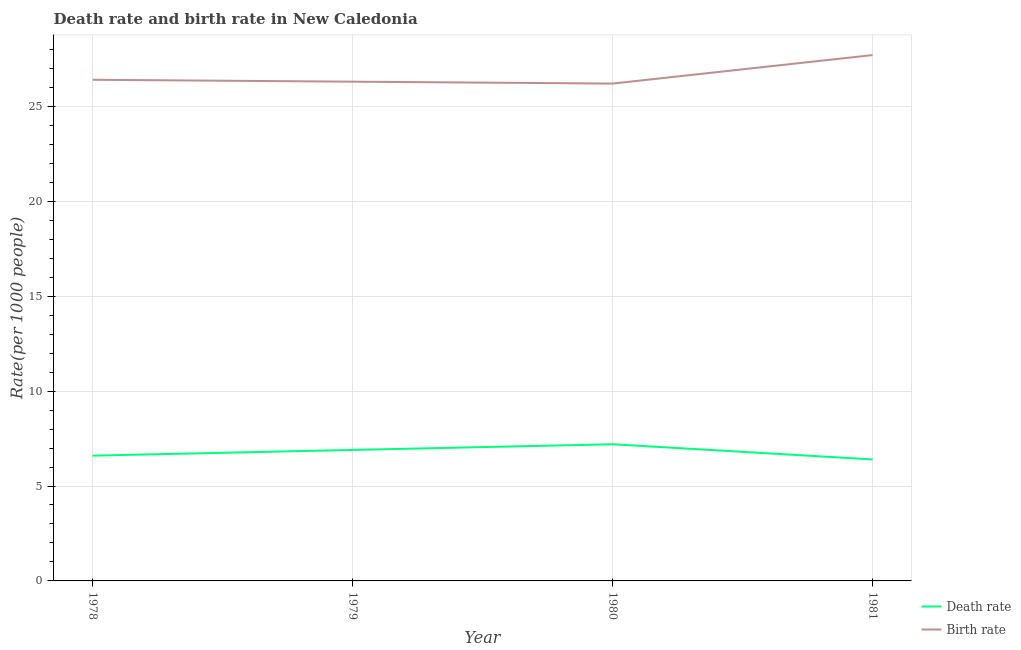How many different coloured lines are there?
Keep it short and to the point. 2. Does the line corresponding to birth rate intersect with the line corresponding to death rate?
Provide a short and direct response. No. Is the number of lines equal to the number of legend labels?
Ensure brevity in your answer.  Yes. What is the death rate in 1978?
Provide a short and direct response. 6.6. Across all years, what is the maximum death rate?
Make the answer very short. 7.2. What is the total death rate in the graph?
Offer a terse response. 27.1. What is the difference between the death rate in 1978 and that in 1980?
Make the answer very short. -0.6. What is the difference between the birth rate in 1979 and the death rate in 1978?
Make the answer very short. 19.7. What is the average death rate per year?
Keep it short and to the point. 6.78. In the year 1981, what is the difference between the birth rate and death rate?
Make the answer very short. 21.3. In how many years, is the death rate greater than 6?
Your response must be concise. 4. What is the ratio of the death rate in 1979 to that in 1981?
Offer a very short reply. 1.08. Is the death rate in 1980 less than that in 1981?
Keep it short and to the point. No. Is the difference between the death rate in 1978 and 1981 greater than the difference between the birth rate in 1978 and 1981?
Your answer should be compact. Yes. What is the difference between the highest and the second highest birth rate?
Keep it short and to the point. 1.3. What is the difference between the highest and the lowest death rate?
Your response must be concise. 0.8. In how many years, is the death rate greater than the average death rate taken over all years?
Offer a very short reply. 2. Is the sum of the death rate in 1980 and 1981 greater than the maximum birth rate across all years?
Keep it short and to the point. No. Does the death rate monotonically increase over the years?
Your response must be concise. No. Is the death rate strictly greater than the birth rate over the years?
Offer a very short reply. No. How many lines are there?
Keep it short and to the point. 2. How are the legend labels stacked?
Your response must be concise. Vertical. What is the title of the graph?
Ensure brevity in your answer.  Death rate and birth rate in New Caledonia. What is the label or title of the Y-axis?
Offer a terse response. Rate(per 1000 people). What is the Rate(per 1000 people) of Death rate in 1978?
Your answer should be very brief. 6.6. What is the Rate(per 1000 people) in Birth rate in 1978?
Provide a succinct answer. 26.4. What is the Rate(per 1000 people) of Death rate in 1979?
Your response must be concise. 6.9. What is the Rate(per 1000 people) in Birth rate in 1979?
Make the answer very short. 26.3. What is the Rate(per 1000 people) in Death rate in 1980?
Your response must be concise. 7.2. What is the Rate(per 1000 people) of Birth rate in 1980?
Offer a very short reply. 26.2. What is the Rate(per 1000 people) of Death rate in 1981?
Your answer should be very brief. 6.4. What is the Rate(per 1000 people) of Birth rate in 1981?
Keep it short and to the point. 27.7. Across all years, what is the maximum Rate(per 1000 people) of Death rate?
Make the answer very short. 7.2. Across all years, what is the maximum Rate(per 1000 people) in Birth rate?
Your response must be concise. 27.7. Across all years, what is the minimum Rate(per 1000 people) of Death rate?
Give a very brief answer. 6.4. Across all years, what is the minimum Rate(per 1000 people) in Birth rate?
Offer a very short reply. 26.2. What is the total Rate(per 1000 people) in Death rate in the graph?
Offer a terse response. 27.1. What is the total Rate(per 1000 people) of Birth rate in the graph?
Your response must be concise. 106.6. What is the difference between the Rate(per 1000 people) of Death rate in 1978 and that in 1980?
Keep it short and to the point. -0.6. What is the difference between the Rate(per 1000 people) of Birth rate in 1978 and that in 1980?
Make the answer very short. 0.2. What is the difference between the Rate(per 1000 people) in Death rate in 1978 and that in 1981?
Provide a short and direct response. 0.2. What is the difference between the Rate(per 1000 people) in Birth rate in 1978 and that in 1981?
Give a very brief answer. -1.3. What is the difference between the Rate(per 1000 people) of Death rate in 1979 and that in 1981?
Keep it short and to the point. 0.5. What is the difference between the Rate(per 1000 people) in Birth rate in 1980 and that in 1981?
Your answer should be compact. -1.5. What is the difference between the Rate(per 1000 people) of Death rate in 1978 and the Rate(per 1000 people) of Birth rate in 1979?
Provide a short and direct response. -19.7. What is the difference between the Rate(per 1000 people) of Death rate in 1978 and the Rate(per 1000 people) of Birth rate in 1980?
Provide a succinct answer. -19.6. What is the difference between the Rate(per 1000 people) in Death rate in 1978 and the Rate(per 1000 people) in Birth rate in 1981?
Keep it short and to the point. -21.1. What is the difference between the Rate(per 1000 people) in Death rate in 1979 and the Rate(per 1000 people) in Birth rate in 1980?
Provide a succinct answer. -19.3. What is the difference between the Rate(per 1000 people) of Death rate in 1979 and the Rate(per 1000 people) of Birth rate in 1981?
Ensure brevity in your answer.  -20.8. What is the difference between the Rate(per 1000 people) of Death rate in 1980 and the Rate(per 1000 people) of Birth rate in 1981?
Ensure brevity in your answer.  -20.5. What is the average Rate(per 1000 people) in Death rate per year?
Keep it short and to the point. 6.78. What is the average Rate(per 1000 people) of Birth rate per year?
Provide a short and direct response. 26.65. In the year 1978, what is the difference between the Rate(per 1000 people) of Death rate and Rate(per 1000 people) of Birth rate?
Provide a succinct answer. -19.8. In the year 1979, what is the difference between the Rate(per 1000 people) of Death rate and Rate(per 1000 people) of Birth rate?
Offer a very short reply. -19.4. In the year 1980, what is the difference between the Rate(per 1000 people) of Death rate and Rate(per 1000 people) of Birth rate?
Provide a short and direct response. -19. In the year 1981, what is the difference between the Rate(per 1000 people) of Death rate and Rate(per 1000 people) of Birth rate?
Keep it short and to the point. -21.3. What is the ratio of the Rate(per 1000 people) in Death rate in 1978 to that in 1979?
Give a very brief answer. 0.96. What is the ratio of the Rate(per 1000 people) in Birth rate in 1978 to that in 1979?
Your response must be concise. 1. What is the ratio of the Rate(per 1000 people) in Death rate in 1978 to that in 1980?
Offer a terse response. 0.92. What is the ratio of the Rate(per 1000 people) of Birth rate in 1978 to that in 1980?
Make the answer very short. 1.01. What is the ratio of the Rate(per 1000 people) in Death rate in 1978 to that in 1981?
Offer a terse response. 1.03. What is the ratio of the Rate(per 1000 people) in Birth rate in 1978 to that in 1981?
Keep it short and to the point. 0.95. What is the ratio of the Rate(per 1000 people) in Birth rate in 1979 to that in 1980?
Give a very brief answer. 1. What is the ratio of the Rate(per 1000 people) in Death rate in 1979 to that in 1981?
Keep it short and to the point. 1.08. What is the ratio of the Rate(per 1000 people) in Birth rate in 1979 to that in 1981?
Make the answer very short. 0.95. What is the ratio of the Rate(per 1000 people) of Death rate in 1980 to that in 1981?
Your response must be concise. 1.12. What is the ratio of the Rate(per 1000 people) in Birth rate in 1980 to that in 1981?
Make the answer very short. 0.95. What is the difference between the highest and the second highest Rate(per 1000 people) in Birth rate?
Make the answer very short. 1.3. What is the difference between the highest and the lowest Rate(per 1000 people) in Death rate?
Provide a succinct answer. 0.8. What is the difference between the highest and the lowest Rate(per 1000 people) in Birth rate?
Offer a terse response. 1.5. 